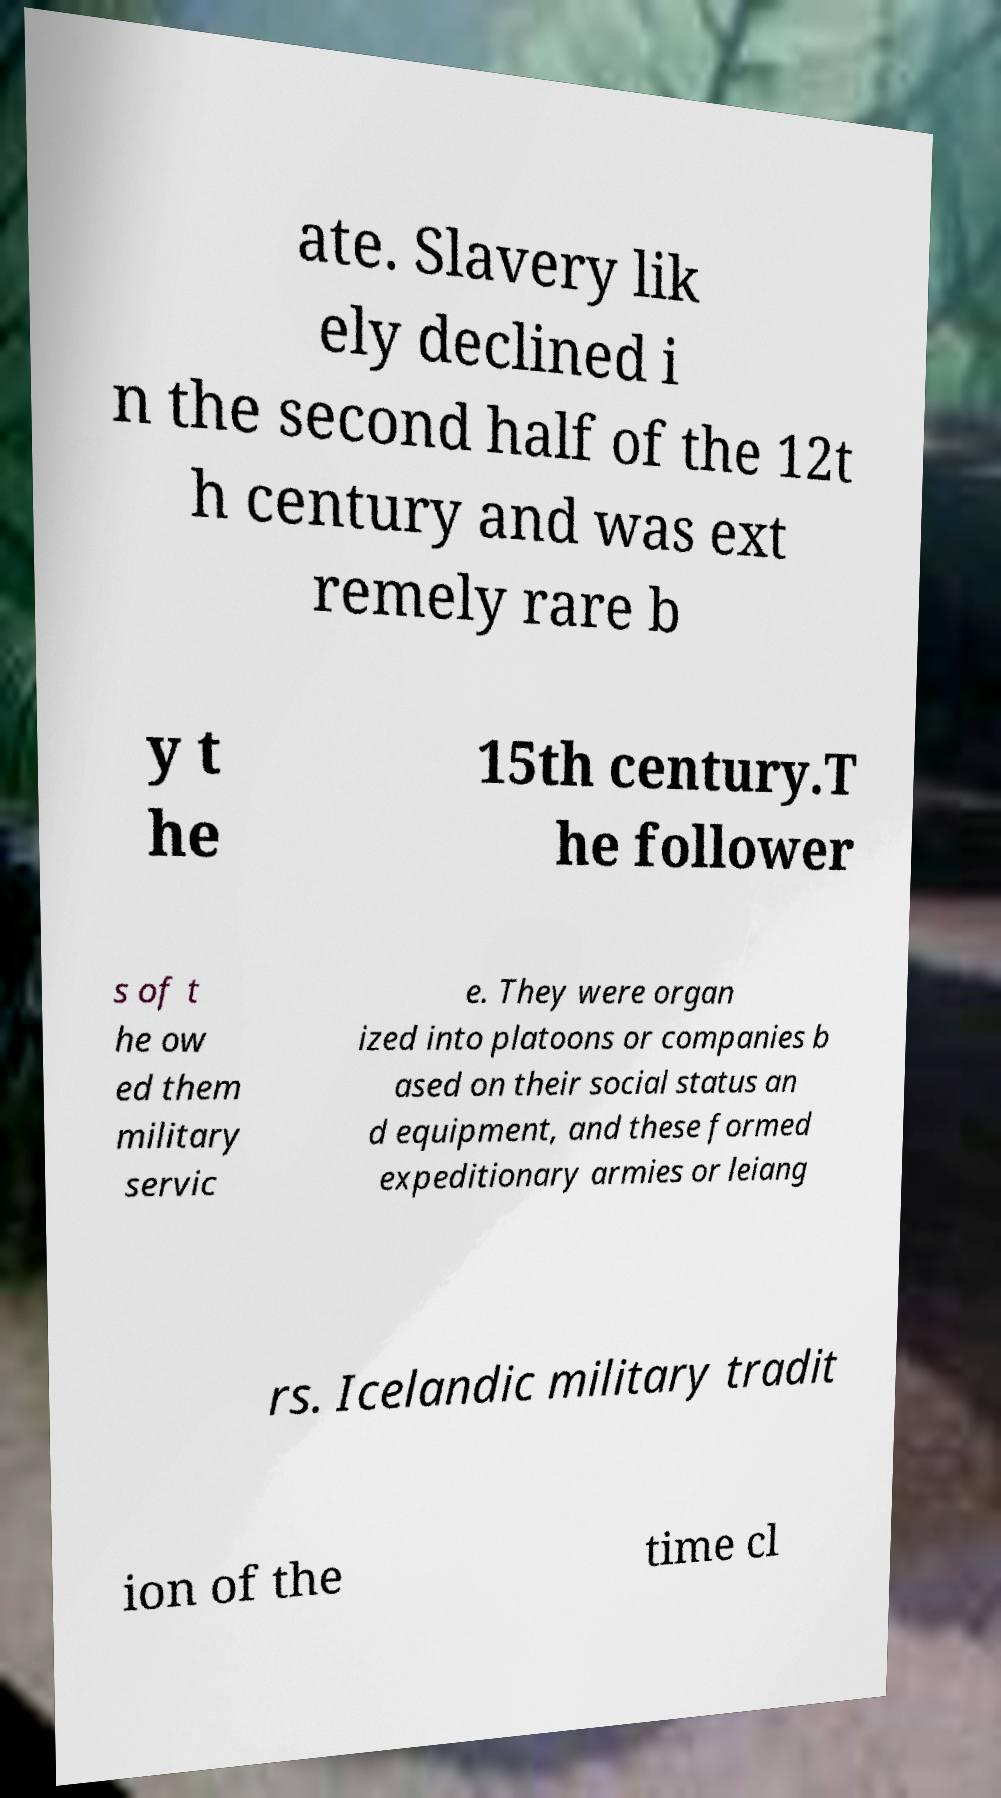I need the written content from this picture converted into text. Can you do that? ate. Slavery lik ely declined i n the second half of the 12t h century and was ext remely rare b y t he 15th century.T he follower s of t he ow ed them military servic e. They were organ ized into platoons or companies b ased on their social status an d equipment, and these formed expeditionary armies or leiang rs. Icelandic military tradit ion of the time cl 